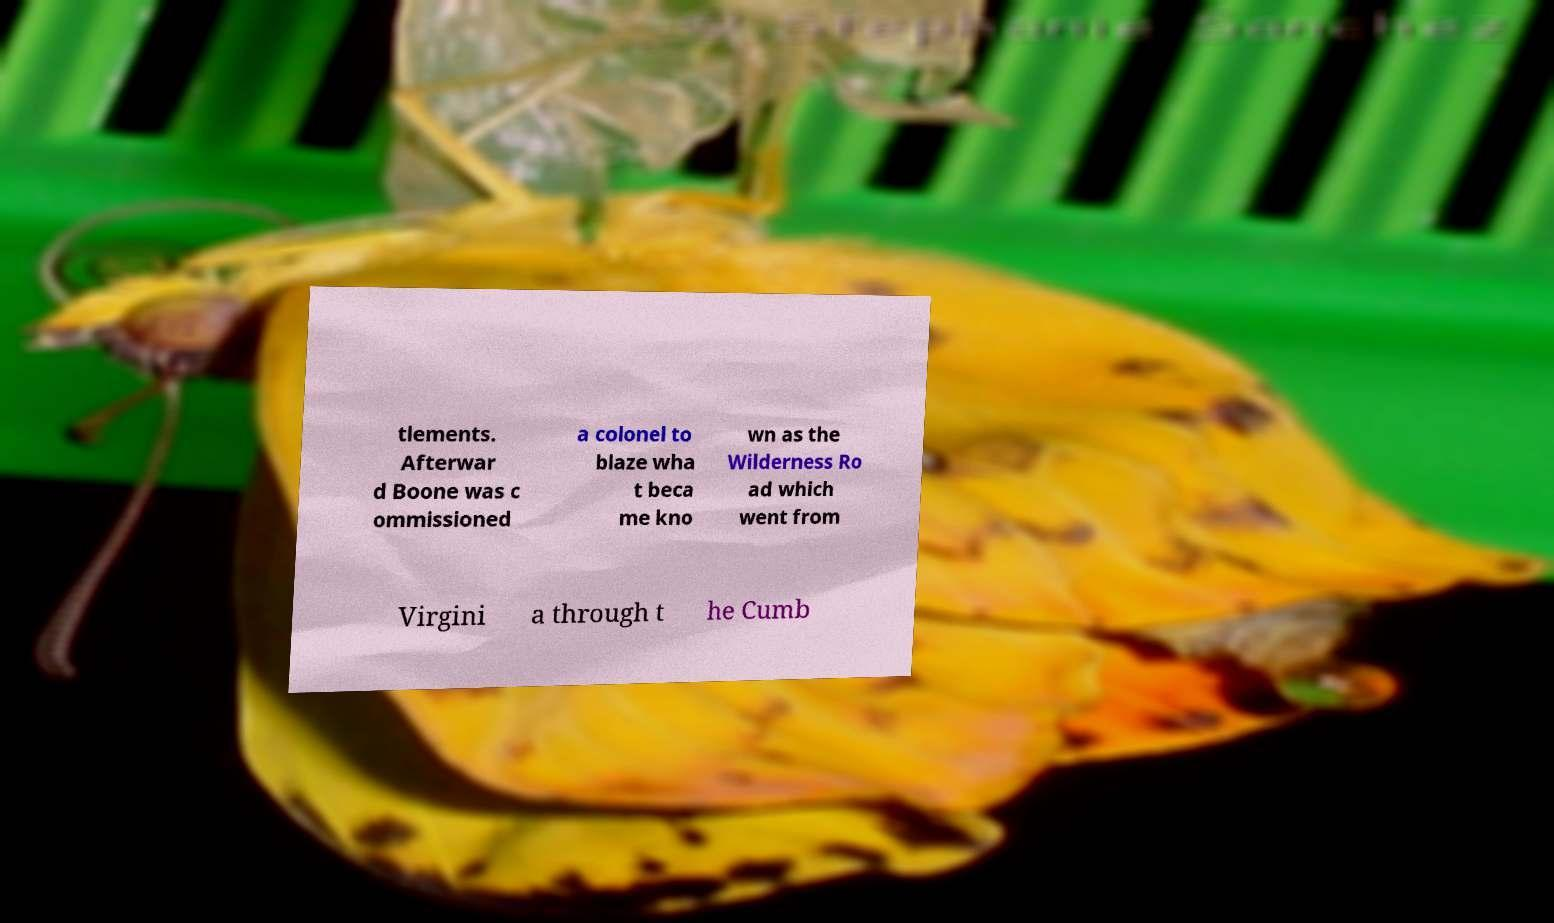For documentation purposes, I need the text within this image transcribed. Could you provide that? tlements. Afterwar d Boone was c ommissioned a colonel to blaze wha t beca me kno wn as the Wilderness Ro ad which went from Virgini a through t he Cumb 